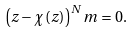<formula> <loc_0><loc_0><loc_500><loc_500>\left ( z - \chi \left ( z \right ) \right ) ^ { N } m = 0 .</formula> 